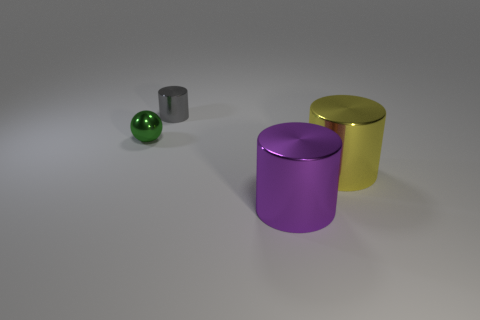Add 4 shiny cylinders. How many objects exist? 8 Subtract all cylinders. How many objects are left? 1 Subtract all small cyan things. Subtract all gray shiny objects. How many objects are left? 3 Add 1 purple metal things. How many purple metal things are left? 2 Add 3 small metal things. How many small metal things exist? 5 Subtract 0 yellow cubes. How many objects are left? 4 